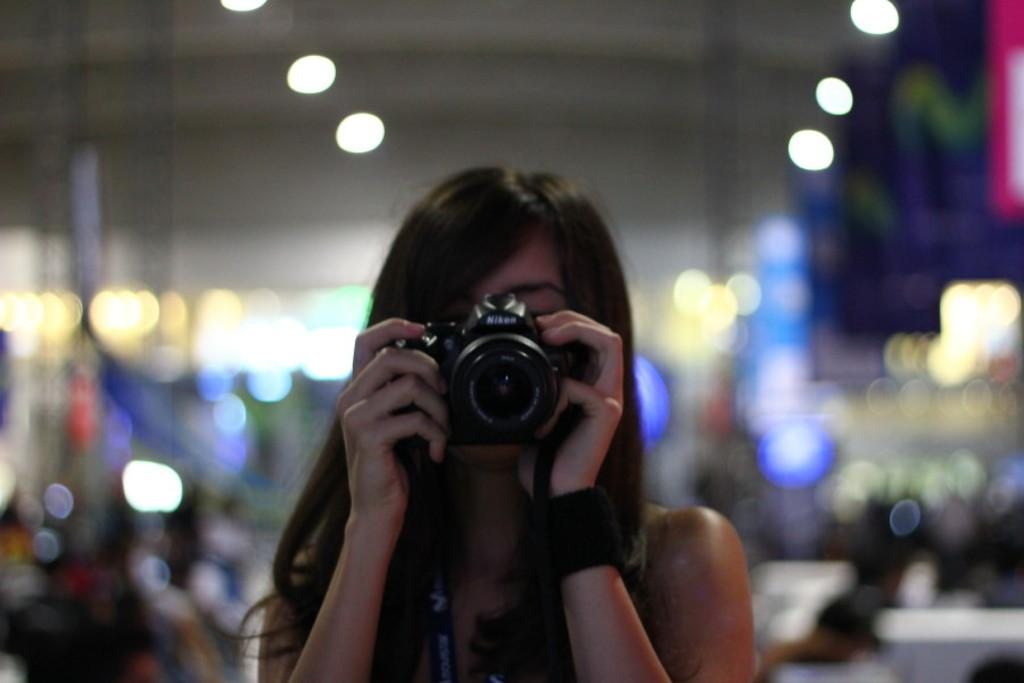Who is the main subject in the image? There is a woman in the image. What is the woman holding in her hands? The woman is holding a camera in her hands. What can be seen in the background of the image? There are lights in the background of the image. Can you see any giants or a harbor in the image? No, there are no giants or harbor visible in the image. Is the woman standing near a coast in the image? The provided facts do not mention a coast, so it cannot be determined from the image. 